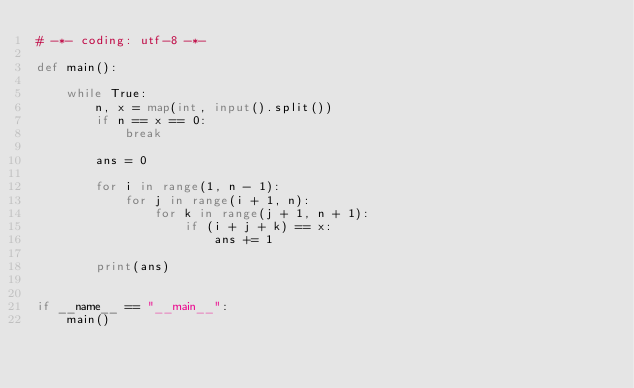<code> <loc_0><loc_0><loc_500><loc_500><_Python_># -*- coding: utf-8 -*-

def main():

    while True:
        n, x = map(int, input().split())
        if n == x == 0:
            break

        ans = 0

        for i in range(1, n - 1):
            for j in range(i + 1, n):
                for k in range(j + 1, n + 1):
                    if (i + j + k) == x:
                        ans += 1

        print(ans)


if __name__ == "__main__":
    main()
</code> 